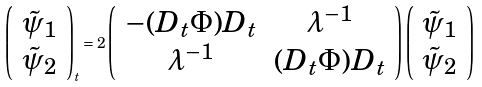Convert formula to latex. <formula><loc_0><loc_0><loc_500><loc_500>\left ( \begin{array} { c c } { \tilde { \psi } } _ { 1 } \\ { \tilde { \psi } } _ { 2 } \end{array} \right ) _ { t } = 2 \left ( \begin{array} { c c } - ( D _ { t } \Phi ) D _ { t } & \lambda ^ { - 1 } \\ \lambda ^ { - 1 } & ( D _ { t } \Phi ) D _ { t } \end{array} \right ) \left ( \begin{array} { c c } { \tilde { \psi } } _ { 1 } \\ { \tilde { \psi } } _ { 2 } \end{array} \right )</formula> 